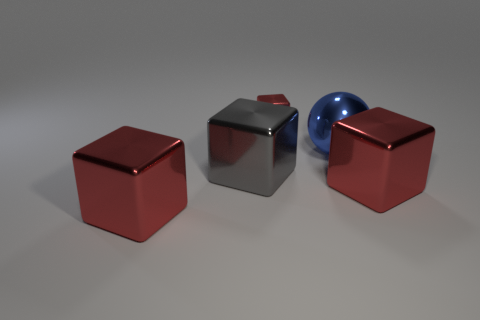What color is the metallic ball that is the same size as the gray object?
Offer a very short reply. Blue. Are there any big gray objects that have the same shape as the tiny red shiny object?
Offer a terse response. Yes. Are there fewer big blue spheres than red blocks?
Your answer should be compact. Yes. There is a sphere in front of the small object; what color is it?
Keep it short and to the point. Blue. There is a large red thing right of the large red shiny object that is on the left side of the gray thing; what shape is it?
Keep it short and to the point. Cube. Is the material of the tiny cube the same as the red block that is on the right side of the tiny shiny block?
Make the answer very short. Yes. What number of red objects have the same size as the ball?
Provide a short and direct response. 2. Is the number of big gray metal cubes behind the small red block less than the number of big things?
Provide a short and direct response. Yes. How many big gray metallic things are in front of the small cube?
Offer a terse response. 1. There is a metal cube on the right side of the red block behind the large block that is on the right side of the blue ball; what size is it?
Provide a short and direct response. Large. 